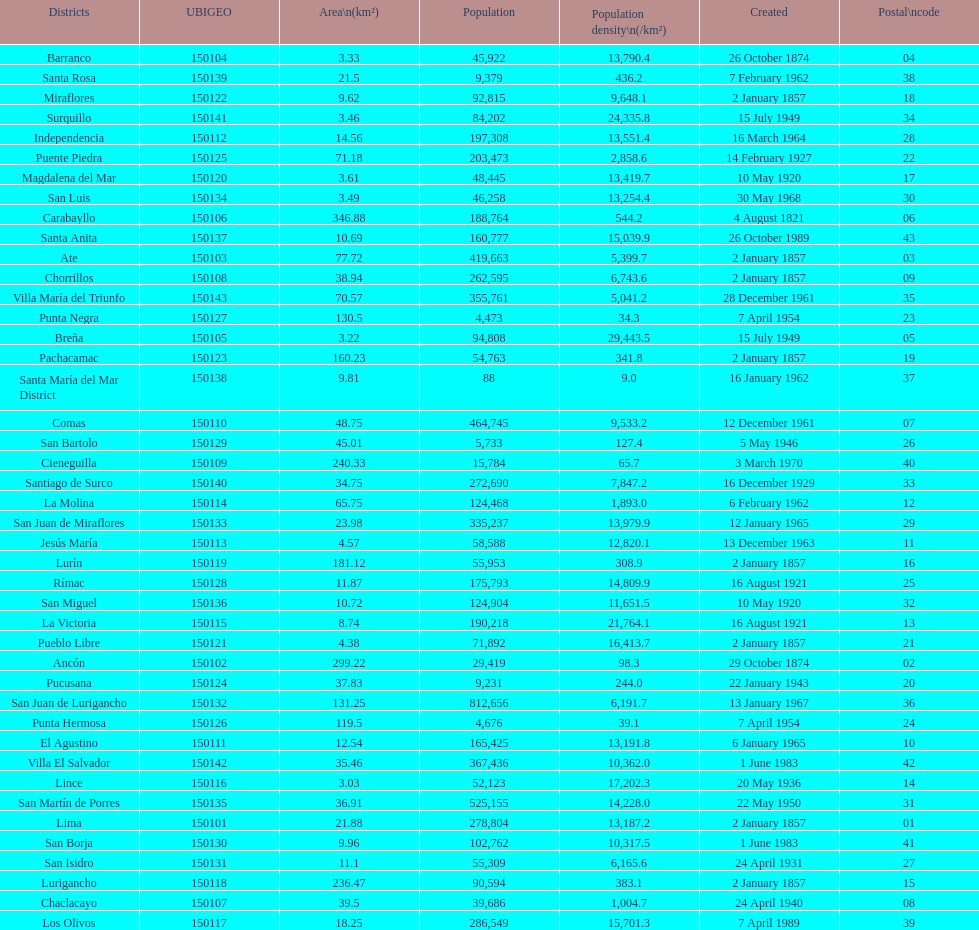Which is the largest district in terms of population? San Juan de Lurigancho. 